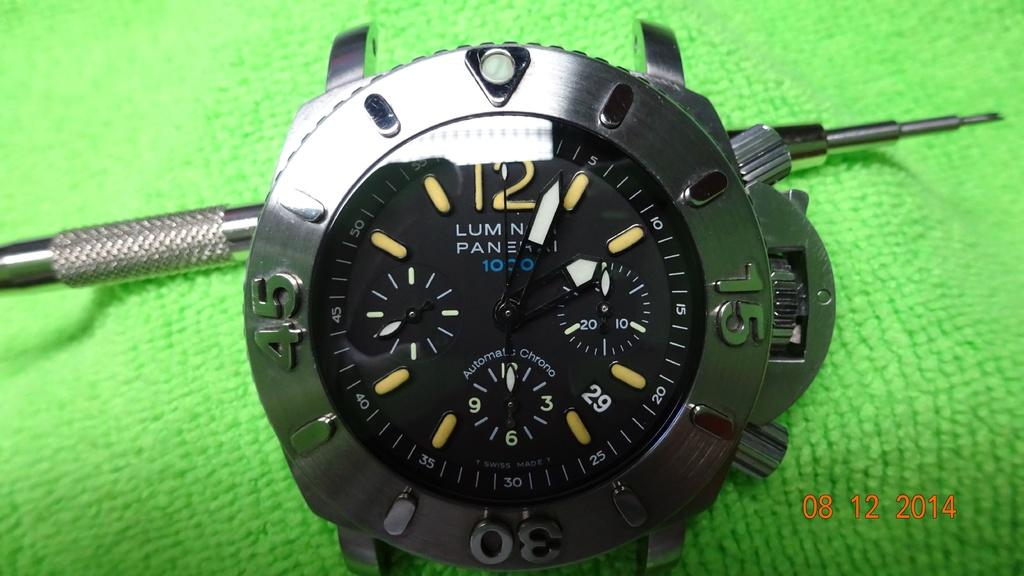<image>
Summarize the visual content of the image. Metallic black Luminor Panerai men's watch with no straps, 4 faces in one. 